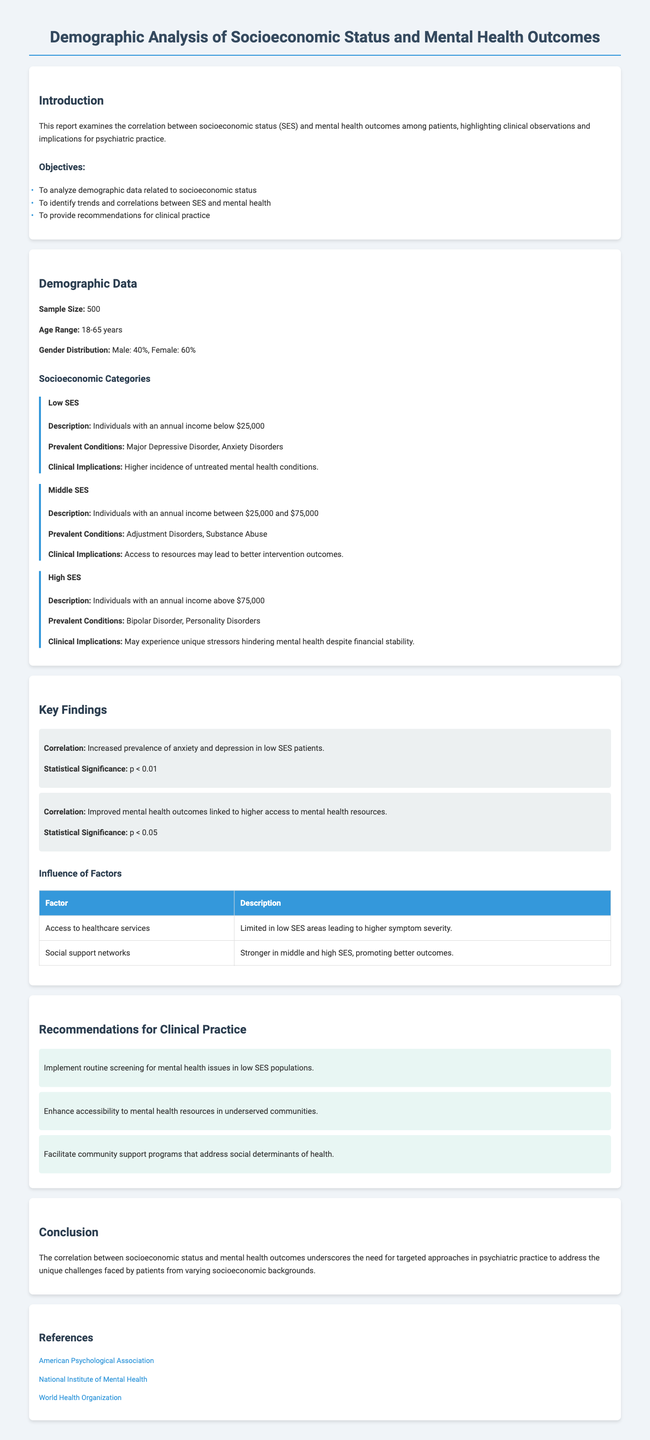What is the sample size? The sample size mentioned in the document is 500 patients.
Answer: 500 What is the age range of the study participants? The document states that the age range of the participants is between 18 to 65 years.
Answer: 18-65 years What percentage of the participants are female? The document indicates that 60% of the participants are female.
Answer: 60% What prevalent condition is associated with low socioeconomic status? According to the document, Major Depressive Disorder is a prevalent condition in low SES individuals.
Answer: Major Depressive Disorder What correlation is mentioned concerning low SES patients? The document highlights an increased prevalence of anxiety and depression among low SES patients.
Answer: Increased prevalence of anxiety and depression What is a recommendation for clinical practice provided in the document? The document suggests implementing routine screening for mental health issues in low SES populations.
Answer: Implement routine screening for mental health issues Which factor is associated with higher symptom severity? The document states that limited access to healthcare services is associated with higher symptom severity in low SES areas.
Answer: Access to healthcare services What is the statistical significance level for the correlation in low SES patients? The document specifies that the statistical significance level is p < 0.01 for the correlation related to low SES patients.
Answer: p < 0.01 